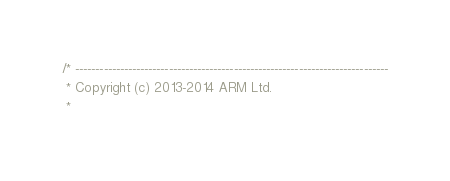Convert code to text. <code><loc_0><loc_0><loc_500><loc_500><_C_>/* -----------------------------------------------------------------------------
 * Copyright (c) 2013-2014 ARM Ltd.
 *</code> 